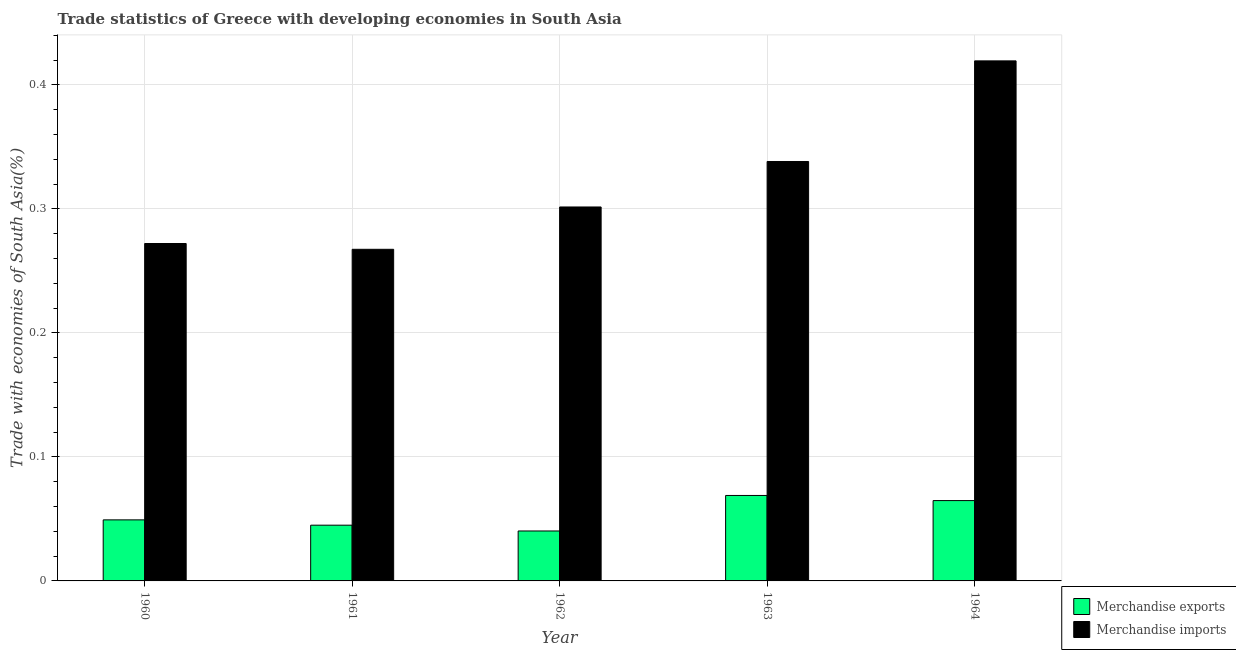How many different coloured bars are there?
Your answer should be very brief. 2. How many groups of bars are there?
Keep it short and to the point. 5. Are the number of bars on each tick of the X-axis equal?
Give a very brief answer. Yes. How many bars are there on the 1st tick from the left?
Give a very brief answer. 2. How many bars are there on the 5th tick from the right?
Keep it short and to the point. 2. What is the label of the 5th group of bars from the left?
Make the answer very short. 1964. What is the merchandise exports in 1964?
Offer a very short reply. 0.06. Across all years, what is the maximum merchandise exports?
Your response must be concise. 0.07. Across all years, what is the minimum merchandise imports?
Offer a terse response. 0.27. In which year was the merchandise imports maximum?
Your answer should be very brief. 1964. In which year was the merchandise imports minimum?
Your answer should be very brief. 1961. What is the total merchandise exports in the graph?
Offer a very short reply. 0.27. What is the difference between the merchandise imports in 1960 and that in 1962?
Offer a terse response. -0.03. What is the difference between the merchandise exports in 1963 and the merchandise imports in 1960?
Your answer should be very brief. 0.02. What is the average merchandise exports per year?
Ensure brevity in your answer.  0.05. In the year 1963, what is the difference between the merchandise exports and merchandise imports?
Ensure brevity in your answer.  0. What is the ratio of the merchandise exports in 1960 to that in 1963?
Your answer should be very brief. 0.71. Is the difference between the merchandise exports in 1961 and 1962 greater than the difference between the merchandise imports in 1961 and 1962?
Provide a succinct answer. No. What is the difference between the highest and the second highest merchandise imports?
Offer a terse response. 0.08. What is the difference between the highest and the lowest merchandise exports?
Your response must be concise. 0.03. In how many years, is the merchandise exports greater than the average merchandise exports taken over all years?
Ensure brevity in your answer.  2. What is the difference between two consecutive major ticks on the Y-axis?
Provide a succinct answer. 0.1. Does the graph contain grids?
Offer a terse response. Yes. Where does the legend appear in the graph?
Ensure brevity in your answer.  Bottom right. How many legend labels are there?
Keep it short and to the point. 2. How are the legend labels stacked?
Make the answer very short. Vertical. What is the title of the graph?
Offer a terse response. Trade statistics of Greece with developing economies in South Asia. What is the label or title of the Y-axis?
Your answer should be very brief. Trade with economies of South Asia(%). What is the Trade with economies of South Asia(%) in Merchandise exports in 1960?
Your answer should be very brief. 0.05. What is the Trade with economies of South Asia(%) in Merchandise imports in 1960?
Give a very brief answer. 0.27. What is the Trade with economies of South Asia(%) in Merchandise exports in 1961?
Your answer should be very brief. 0.04. What is the Trade with economies of South Asia(%) in Merchandise imports in 1961?
Offer a terse response. 0.27. What is the Trade with economies of South Asia(%) in Merchandise exports in 1962?
Keep it short and to the point. 0.04. What is the Trade with economies of South Asia(%) in Merchandise imports in 1962?
Provide a short and direct response. 0.3. What is the Trade with economies of South Asia(%) in Merchandise exports in 1963?
Your response must be concise. 0.07. What is the Trade with economies of South Asia(%) in Merchandise imports in 1963?
Your response must be concise. 0.34. What is the Trade with economies of South Asia(%) of Merchandise exports in 1964?
Provide a succinct answer. 0.06. What is the Trade with economies of South Asia(%) of Merchandise imports in 1964?
Offer a terse response. 0.42. Across all years, what is the maximum Trade with economies of South Asia(%) of Merchandise exports?
Offer a terse response. 0.07. Across all years, what is the maximum Trade with economies of South Asia(%) in Merchandise imports?
Ensure brevity in your answer.  0.42. Across all years, what is the minimum Trade with economies of South Asia(%) of Merchandise exports?
Provide a short and direct response. 0.04. Across all years, what is the minimum Trade with economies of South Asia(%) in Merchandise imports?
Make the answer very short. 0.27. What is the total Trade with economies of South Asia(%) of Merchandise exports in the graph?
Your response must be concise. 0.27. What is the total Trade with economies of South Asia(%) of Merchandise imports in the graph?
Make the answer very short. 1.6. What is the difference between the Trade with economies of South Asia(%) in Merchandise exports in 1960 and that in 1961?
Your answer should be very brief. 0. What is the difference between the Trade with economies of South Asia(%) in Merchandise imports in 1960 and that in 1961?
Give a very brief answer. 0. What is the difference between the Trade with economies of South Asia(%) of Merchandise exports in 1960 and that in 1962?
Ensure brevity in your answer.  0.01. What is the difference between the Trade with economies of South Asia(%) in Merchandise imports in 1960 and that in 1962?
Make the answer very short. -0.03. What is the difference between the Trade with economies of South Asia(%) of Merchandise exports in 1960 and that in 1963?
Make the answer very short. -0.02. What is the difference between the Trade with economies of South Asia(%) in Merchandise imports in 1960 and that in 1963?
Your response must be concise. -0.07. What is the difference between the Trade with economies of South Asia(%) in Merchandise exports in 1960 and that in 1964?
Your response must be concise. -0.02. What is the difference between the Trade with economies of South Asia(%) in Merchandise imports in 1960 and that in 1964?
Your response must be concise. -0.15. What is the difference between the Trade with economies of South Asia(%) in Merchandise exports in 1961 and that in 1962?
Provide a succinct answer. 0. What is the difference between the Trade with economies of South Asia(%) in Merchandise imports in 1961 and that in 1962?
Ensure brevity in your answer.  -0.03. What is the difference between the Trade with economies of South Asia(%) in Merchandise exports in 1961 and that in 1963?
Ensure brevity in your answer.  -0.02. What is the difference between the Trade with economies of South Asia(%) in Merchandise imports in 1961 and that in 1963?
Ensure brevity in your answer.  -0.07. What is the difference between the Trade with economies of South Asia(%) in Merchandise exports in 1961 and that in 1964?
Offer a very short reply. -0.02. What is the difference between the Trade with economies of South Asia(%) in Merchandise imports in 1961 and that in 1964?
Keep it short and to the point. -0.15. What is the difference between the Trade with economies of South Asia(%) of Merchandise exports in 1962 and that in 1963?
Ensure brevity in your answer.  -0.03. What is the difference between the Trade with economies of South Asia(%) of Merchandise imports in 1962 and that in 1963?
Offer a terse response. -0.04. What is the difference between the Trade with economies of South Asia(%) in Merchandise exports in 1962 and that in 1964?
Keep it short and to the point. -0.02. What is the difference between the Trade with economies of South Asia(%) in Merchandise imports in 1962 and that in 1964?
Provide a short and direct response. -0.12. What is the difference between the Trade with economies of South Asia(%) of Merchandise exports in 1963 and that in 1964?
Your response must be concise. 0. What is the difference between the Trade with economies of South Asia(%) of Merchandise imports in 1963 and that in 1964?
Offer a terse response. -0.08. What is the difference between the Trade with economies of South Asia(%) in Merchandise exports in 1960 and the Trade with economies of South Asia(%) in Merchandise imports in 1961?
Your response must be concise. -0.22. What is the difference between the Trade with economies of South Asia(%) of Merchandise exports in 1960 and the Trade with economies of South Asia(%) of Merchandise imports in 1962?
Make the answer very short. -0.25. What is the difference between the Trade with economies of South Asia(%) in Merchandise exports in 1960 and the Trade with economies of South Asia(%) in Merchandise imports in 1963?
Ensure brevity in your answer.  -0.29. What is the difference between the Trade with economies of South Asia(%) of Merchandise exports in 1960 and the Trade with economies of South Asia(%) of Merchandise imports in 1964?
Your answer should be compact. -0.37. What is the difference between the Trade with economies of South Asia(%) in Merchandise exports in 1961 and the Trade with economies of South Asia(%) in Merchandise imports in 1962?
Provide a succinct answer. -0.26. What is the difference between the Trade with economies of South Asia(%) of Merchandise exports in 1961 and the Trade with economies of South Asia(%) of Merchandise imports in 1963?
Provide a short and direct response. -0.29. What is the difference between the Trade with economies of South Asia(%) of Merchandise exports in 1961 and the Trade with economies of South Asia(%) of Merchandise imports in 1964?
Keep it short and to the point. -0.37. What is the difference between the Trade with economies of South Asia(%) in Merchandise exports in 1962 and the Trade with economies of South Asia(%) in Merchandise imports in 1963?
Your answer should be compact. -0.3. What is the difference between the Trade with economies of South Asia(%) of Merchandise exports in 1962 and the Trade with economies of South Asia(%) of Merchandise imports in 1964?
Keep it short and to the point. -0.38. What is the difference between the Trade with economies of South Asia(%) in Merchandise exports in 1963 and the Trade with economies of South Asia(%) in Merchandise imports in 1964?
Offer a terse response. -0.35. What is the average Trade with economies of South Asia(%) of Merchandise exports per year?
Provide a succinct answer. 0.05. What is the average Trade with economies of South Asia(%) of Merchandise imports per year?
Offer a terse response. 0.32. In the year 1960, what is the difference between the Trade with economies of South Asia(%) of Merchandise exports and Trade with economies of South Asia(%) of Merchandise imports?
Keep it short and to the point. -0.22. In the year 1961, what is the difference between the Trade with economies of South Asia(%) in Merchandise exports and Trade with economies of South Asia(%) in Merchandise imports?
Give a very brief answer. -0.22. In the year 1962, what is the difference between the Trade with economies of South Asia(%) in Merchandise exports and Trade with economies of South Asia(%) in Merchandise imports?
Give a very brief answer. -0.26. In the year 1963, what is the difference between the Trade with economies of South Asia(%) in Merchandise exports and Trade with economies of South Asia(%) in Merchandise imports?
Make the answer very short. -0.27. In the year 1964, what is the difference between the Trade with economies of South Asia(%) in Merchandise exports and Trade with economies of South Asia(%) in Merchandise imports?
Make the answer very short. -0.35. What is the ratio of the Trade with economies of South Asia(%) of Merchandise exports in 1960 to that in 1961?
Offer a very short reply. 1.1. What is the ratio of the Trade with economies of South Asia(%) in Merchandise imports in 1960 to that in 1961?
Give a very brief answer. 1.02. What is the ratio of the Trade with economies of South Asia(%) of Merchandise exports in 1960 to that in 1962?
Provide a short and direct response. 1.22. What is the ratio of the Trade with economies of South Asia(%) of Merchandise imports in 1960 to that in 1962?
Your answer should be very brief. 0.9. What is the ratio of the Trade with economies of South Asia(%) of Merchandise exports in 1960 to that in 1963?
Keep it short and to the point. 0.71. What is the ratio of the Trade with economies of South Asia(%) in Merchandise imports in 1960 to that in 1963?
Give a very brief answer. 0.8. What is the ratio of the Trade with economies of South Asia(%) in Merchandise exports in 1960 to that in 1964?
Your response must be concise. 0.76. What is the ratio of the Trade with economies of South Asia(%) of Merchandise imports in 1960 to that in 1964?
Your answer should be compact. 0.65. What is the ratio of the Trade with economies of South Asia(%) in Merchandise exports in 1961 to that in 1962?
Offer a very short reply. 1.12. What is the ratio of the Trade with economies of South Asia(%) in Merchandise imports in 1961 to that in 1962?
Ensure brevity in your answer.  0.89. What is the ratio of the Trade with economies of South Asia(%) in Merchandise exports in 1961 to that in 1963?
Offer a very short reply. 0.65. What is the ratio of the Trade with economies of South Asia(%) in Merchandise imports in 1961 to that in 1963?
Provide a short and direct response. 0.79. What is the ratio of the Trade with economies of South Asia(%) in Merchandise exports in 1961 to that in 1964?
Your response must be concise. 0.69. What is the ratio of the Trade with economies of South Asia(%) in Merchandise imports in 1961 to that in 1964?
Offer a very short reply. 0.64. What is the ratio of the Trade with economies of South Asia(%) in Merchandise exports in 1962 to that in 1963?
Give a very brief answer. 0.58. What is the ratio of the Trade with economies of South Asia(%) in Merchandise imports in 1962 to that in 1963?
Your answer should be compact. 0.89. What is the ratio of the Trade with economies of South Asia(%) of Merchandise exports in 1962 to that in 1964?
Keep it short and to the point. 0.62. What is the ratio of the Trade with economies of South Asia(%) of Merchandise imports in 1962 to that in 1964?
Ensure brevity in your answer.  0.72. What is the ratio of the Trade with economies of South Asia(%) in Merchandise exports in 1963 to that in 1964?
Offer a terse response. 1.06. What is the ratio of the Trade with economies of South Asia(%) of Merchandise imports in 1963 to that in 1964?
Keep it short and to the point. 0.81. What is the difference between the highest and the second highest Trade with economies of South Asia(%) in Merchandise exports?
Make the answer very short. 0. What is the difference between the highest and the second highest Trade with economies of South Asia(%) of Merchandise imports?
Offer a very short reply. 0.08. What is the difference between the highest and the lowest Trade with economies of South Asia(%) of Merchandise exports?
Offer a very short reply. 0.03. What is the difference between the highest and the lowest Trade with economies of South Asia(%) in Merchandise imports?
Ensure brevity in your answer.  0.15. 